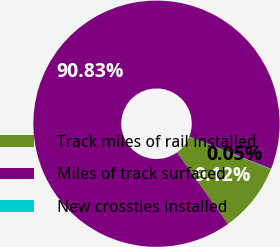Convert chart. <chart><loc_0><loc_0><loc_500><loc_500><pie_chart><fcel>Track miles of rail installed<fcel>Miles of track surfaced<fcel>New crossties installed<nl><fcel>9.12%<fcel>90.83%<fcel>0.05%<nl></chart> 